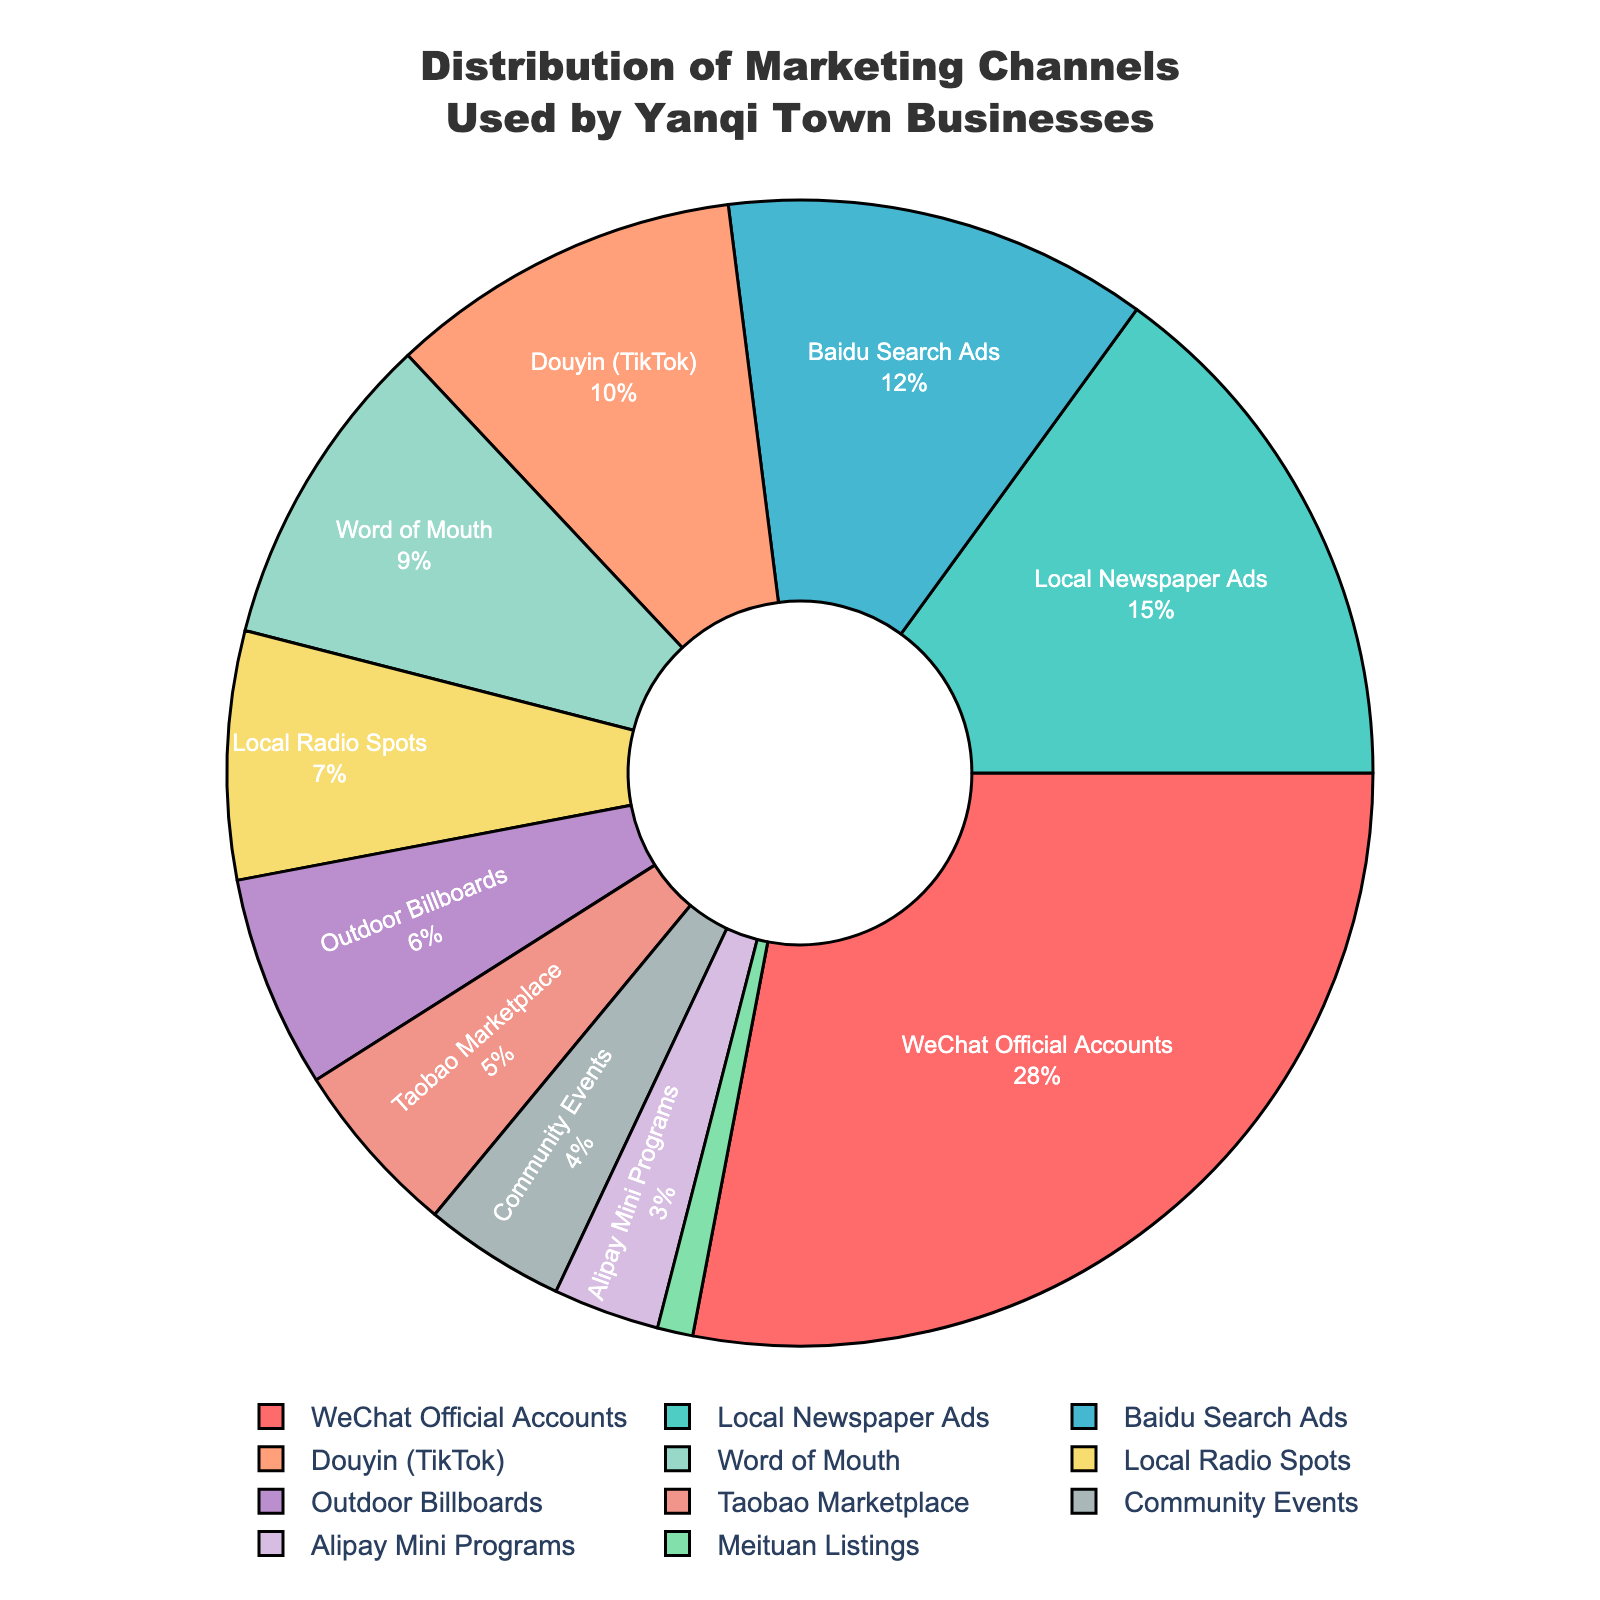What percentage of businesses use WeChat Official Accounts? Look at the pie chart section labeled "WeChat Official Accounts" and check the percentage next to it.
Answer: 28% Which marketing channel is used less, Outdoor Billboards or Local Radio Spots? Compare the percentages for Outdoor Billboards and Local Radio Spots in the pie chart. Outdoor Billboards is 6% and Local Radio Spots is 7%.
Answer: Outdoor Billboards What is the combined percentage for Baidu Search Ads and Douyin (TikTok)? Refer to the pie chart and find the percentages for Baidu Search Ads (12%) and Douyin (10%), then sum these values: 12% + 10%.
Answer: 22% What's the difference in percentage between Local Newspaper Ads and Taobao Marketplace? Identify the percentages for Local Newspaper Ads (15%) and Taobao Marketplace (5%) from the pie chart, then subtract the smaller from the larger: 15% - 5%.
Answer: 10% Among Word of Mouth, Local Radio Spots, and Community Events, which has the highest percentage? Compare the percentages for Word of Mouth (9%), Local Radio Spots (7%), and Community Events (4%) in the pie chart to determine which is highest.
Answer: Word of Mouth How do the marketing channels with the least and most usage compare in percentage terms? Identify the marketing channel with the highest usage (WeChat Official Accounts at 28%) and the one with the least usage (Meituan Listings at 1%). Calculate the difference: 28% - 1%.
Answer: 27% What is the total percentage of marketing channels that use digital platforms? (WeChat Official Accounts, Baidu Search Ads, Douyin, Taobao Marketplace, Alipay Mini Programs, Meituan Listings) Sum up the percentages for the given digital platforms: 28% + 12% + 10% + 5% + 3% + 1%.
Answer: 59% Which channel has a pie slice with a greenish color? Observe the colors in the pie chart and identify which slice is represented by a greenish color. The closest match is Local Newspaper Ads.
Answer: Local Newspaper Ads What is the average percentage of usage for Word of Mouth, Local Radio Spots, and Outdoor Billboards? Calculate the average by adding the percentages for Word of Mouth (9%), Local Radio Spots (7%), and Outdoor Billboards (6%) and then divide by 3: (9% + 7% + 6%) / 3.
Answer: 7.33% 